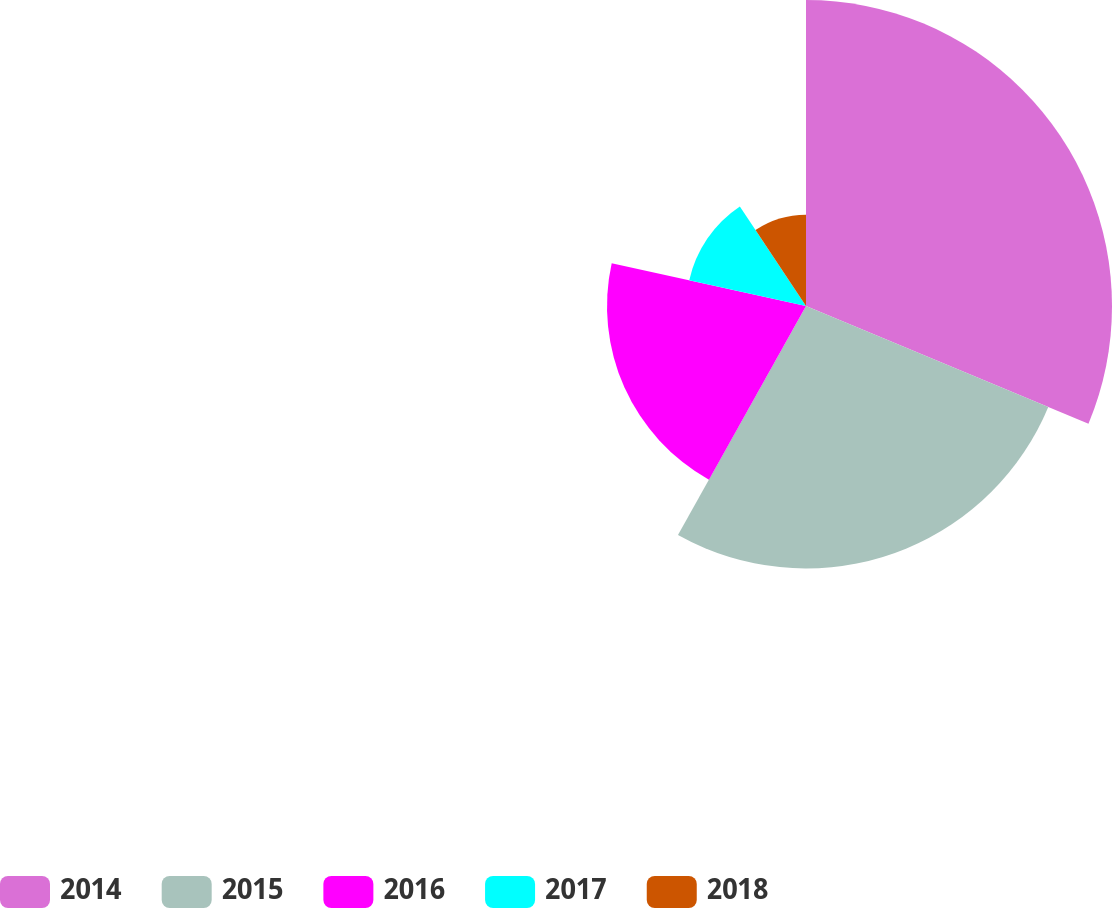Convert chart to OTSL. <chart><loc_0><loc_0><loc_500><loc_500><pie_chart><fcel>2014<fcel>2015<fcel>2016<fcel>2017<fcel>2018<nl><fcel>31.28%<fcel>26.83%<fcel>20.34%<fcel>12.22%<fcel>9.33%<nl></chart> 